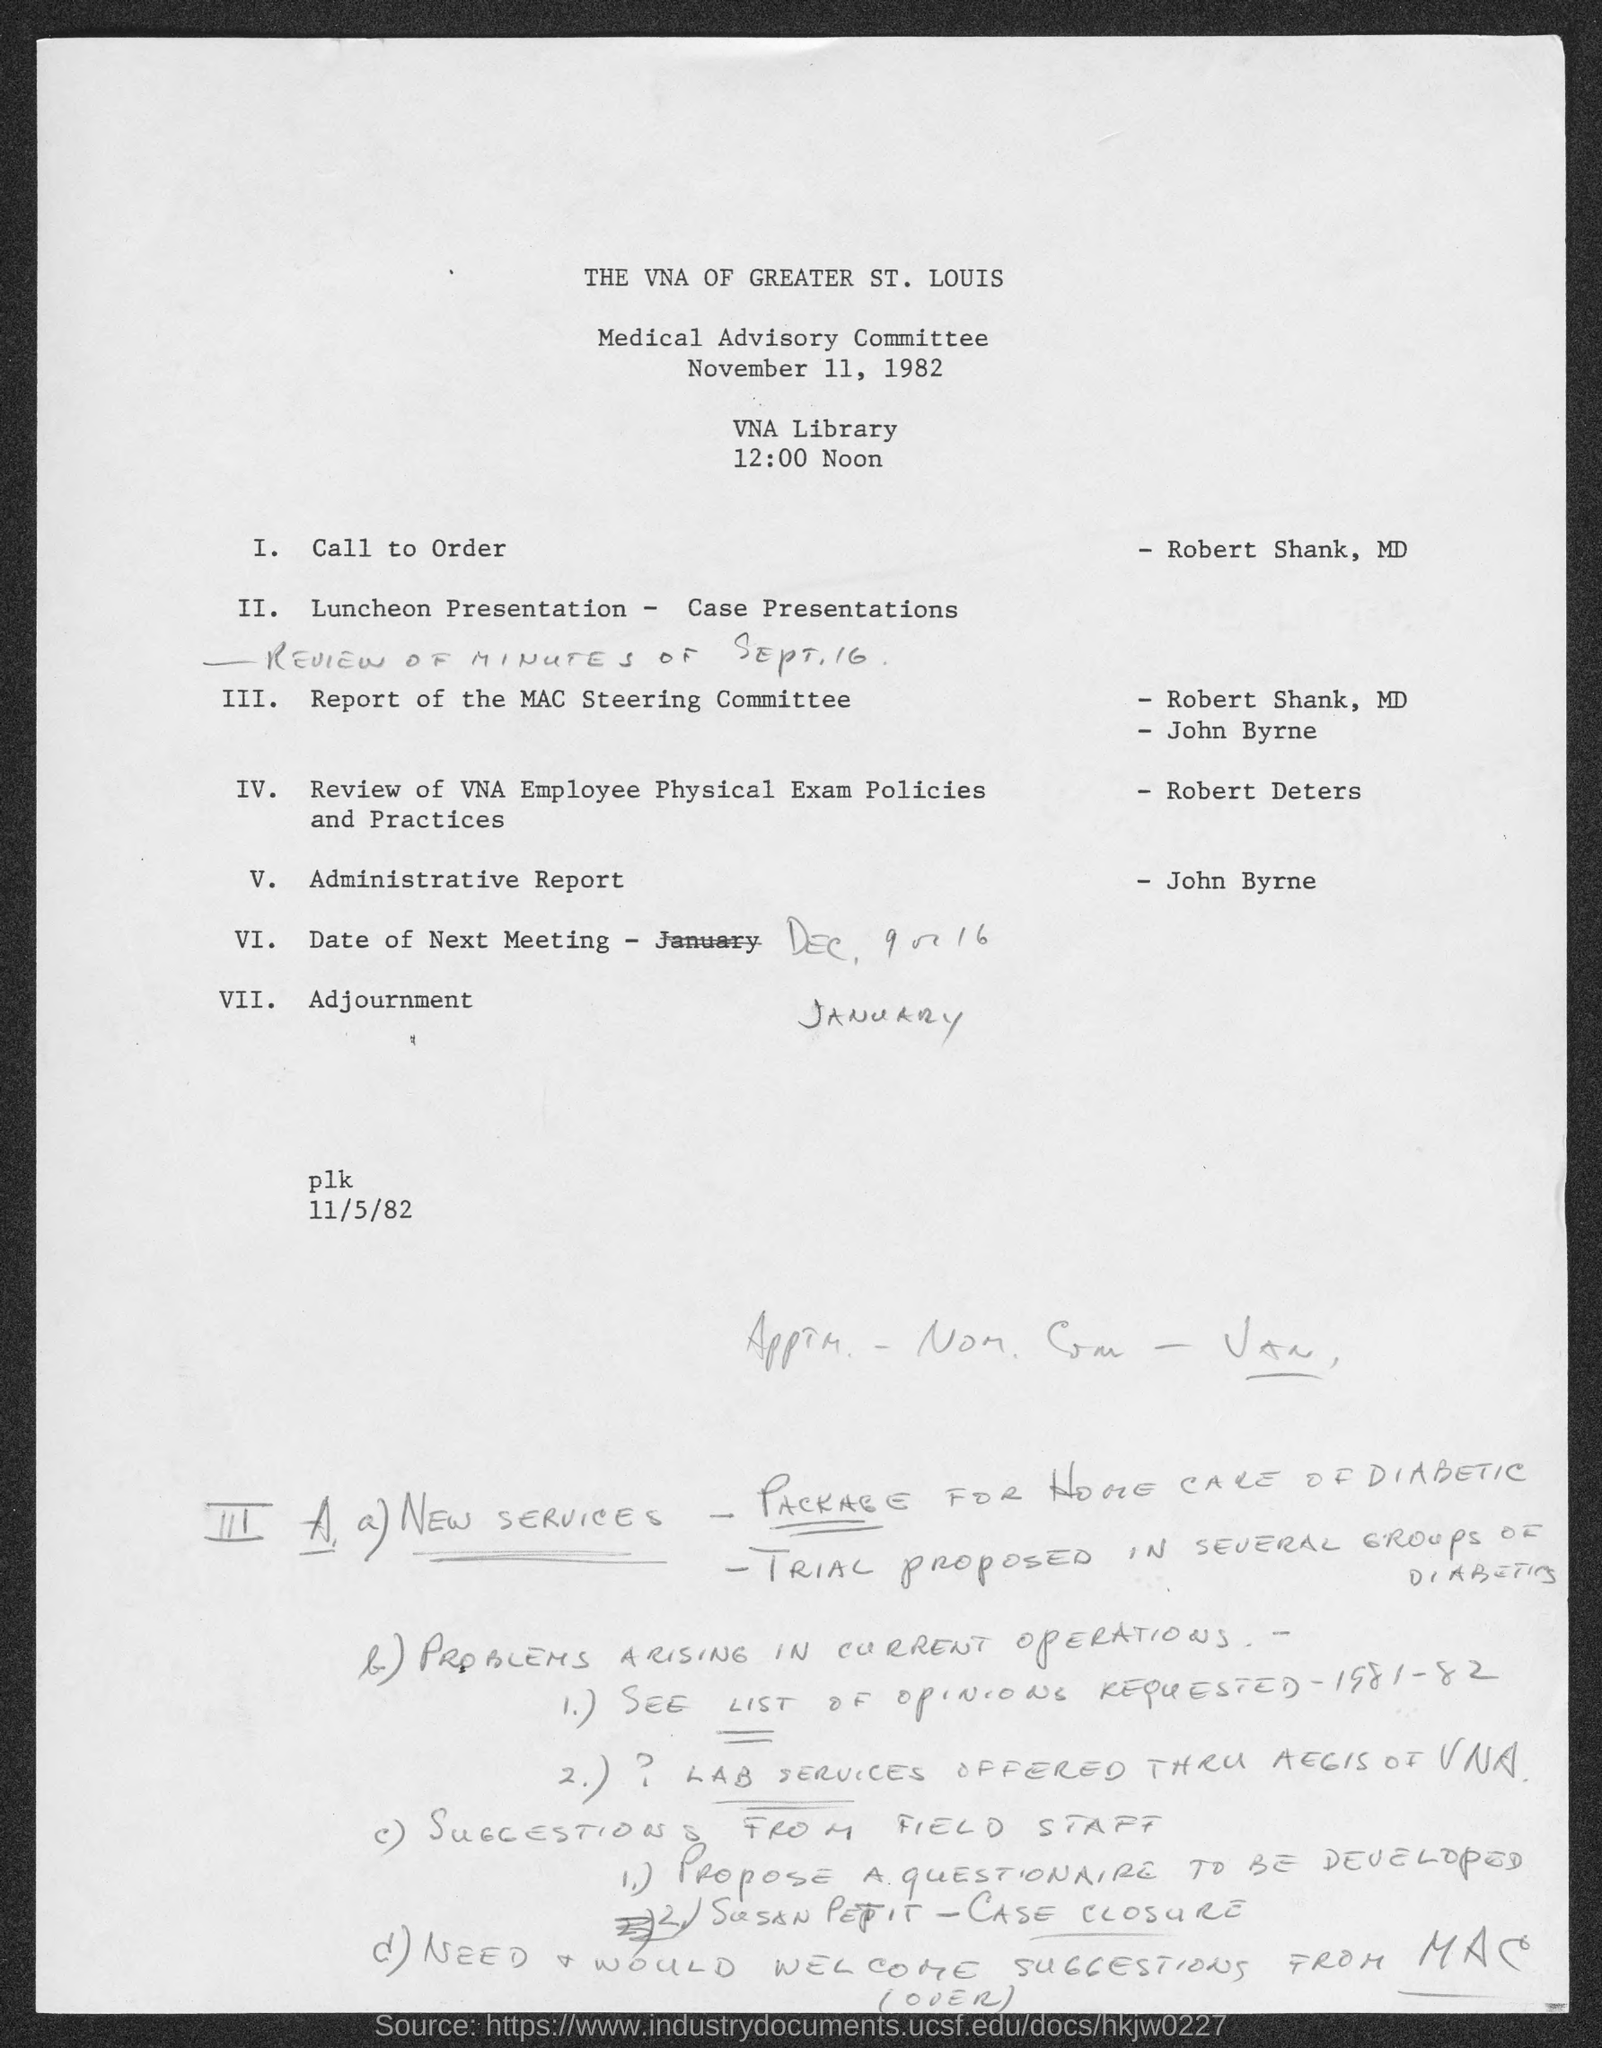When is the Medical Advisory committee held?
Offer a very short reply. NOVEMBER 11, 1982. Where is the Medical Advisory committee held?
Your response must be concise. VNA Library. What Time is the Medical Advisory committee held?
Offer a very short reply. 12:00 Noon. 